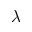Convert formula to latex. <formula><loc_0><loc_0><loc_500><loc_500>\lambda</formula> 